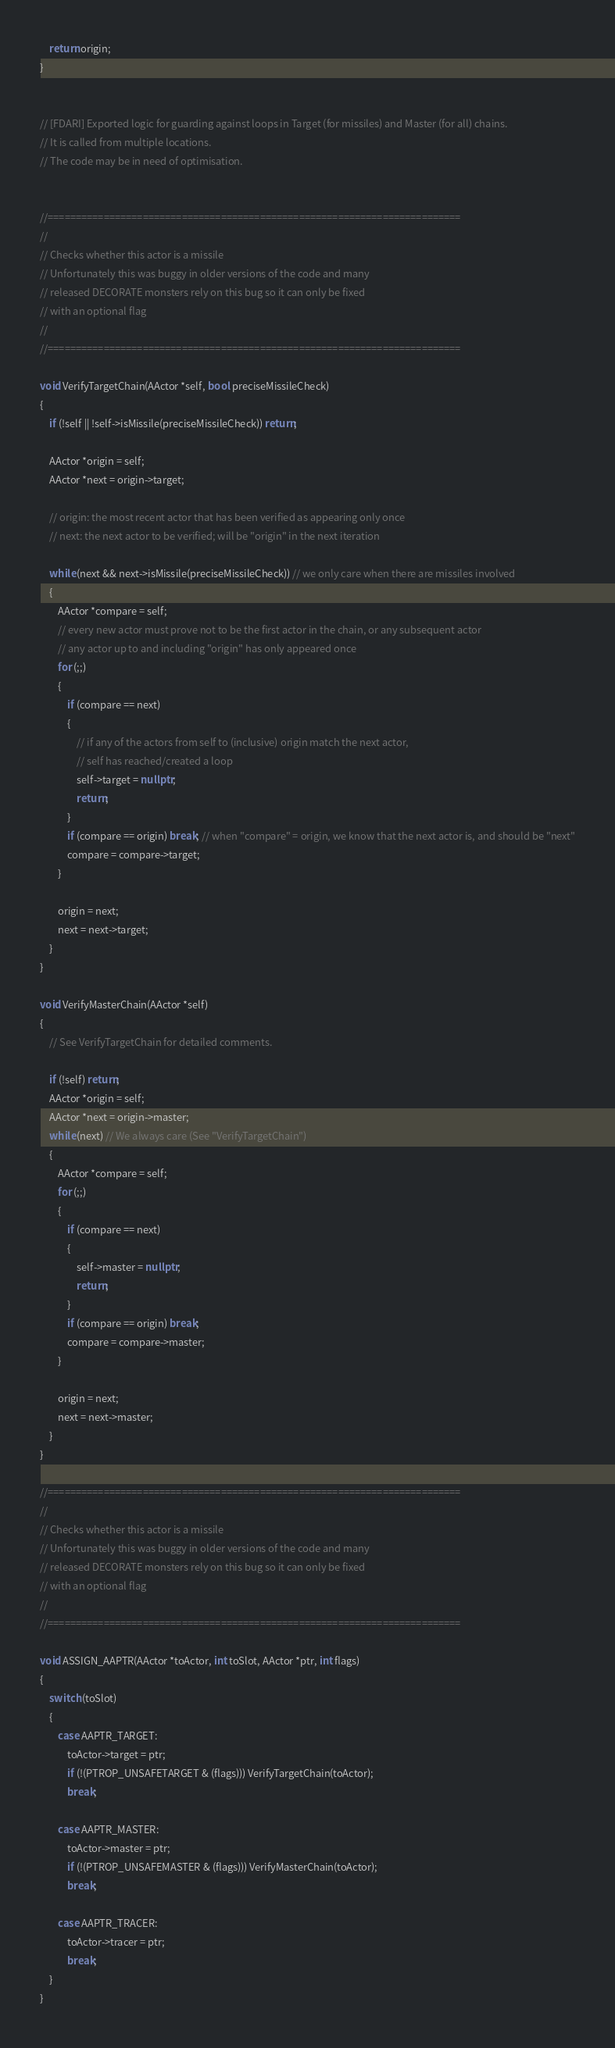<code> <loc_0><loc_0><loc_500><loc_500><_C++_>	return origin;
}


// [FDARI] Exported logic for guarding against loops in Target (for missiles) and Master (for all) chains.
// It is called from multiple locations.
// The code may be in need of optimisation.


//==========================================================================
//
// Checks whether this actor is a missile
// Unfortunately this was buggy in older versions of the code and many
// released DECORATE monsters rely on this bug so it can only be fixed
// with an optional flag
//
//==========================================================================

void VerifyTargetChain(AActor *self, bool preciseMissileCheck)
{
	if (!self || !self->isMissile(preciseMissileCheck)) return;

	AActor *origin = self;
	AActor *next = origin->target;

	// origin: the most recent actor that has been verified as appearing only once
	// next: the next actor to be verified; will be "origin" in the next iteration

	while (next && next->isMissile(preciseMissileCheck)) // we only care when there are missiles involved
	{
		AActor *compare = self;
		// every new actor must prove not to be the first actor in the chain, or any subsequent actor
		// any actor up to and including "origin" has only appeared once
		for (;;)
 		{
			if (compare == next)
			{
				// if any of the actors from self to (inclusive) origin match the next actor,
				// self has reached/created a loop
				self->target = nullptr;
				return;
			}
			if (compare == origin) break; // when "compare" = origin, we know that the next actor is, and should be "next"
			compare = compare->target;
		}

		origin = next;
		next = next->target;
	}
}

void VerifyMasterChain(AActor *self)
{
	// See VerifyTargetChain for detailed comments.

	if (!self) return;
	AActor *origin = self;
	AActor *next = origin->master;
	while (next) // We always care (See "VerifyTargetChain")
	{
		AActor *compare = self;
		for (;;)
		{
			if (compare == next)
			{
				self->master = nullptr;
				return;
			}
			if (compare == origin) break;
			compare = compare->master;
		}

		origin = next;
		next = next->master;
	}
}

//==========================================================================
//
// Checks whether this actor is a missile
// Unfortunately this was buggy in older versions of the code and many
// released DECORATE monsters rely on this bug so it can only be fixed
// with an optional flag
//
//==========================================================================

void ASSIGN_AAPTR(AActor *toActor, int toSlot, AActor *ptr, int flags) 
{
	switch (toSlot)
	{
		case AAPTR_TARGET: 
			toActor->target = ptr; 
			if (!(PTROP_UNSAFETARGET & (flags))) VerifyTargetChain(toActor); 
			break;

		case AAPTR_MASTER: 
			toActor->master = ptr; 
			if (!(PTROP_UNSAFEMASTER & (flags))) VerifyMasterChain(toActor); 
			break;

		case AAPTR_TRACER: 
			toActor->tracer = ptr; 
			break;
	}
}
</code> 